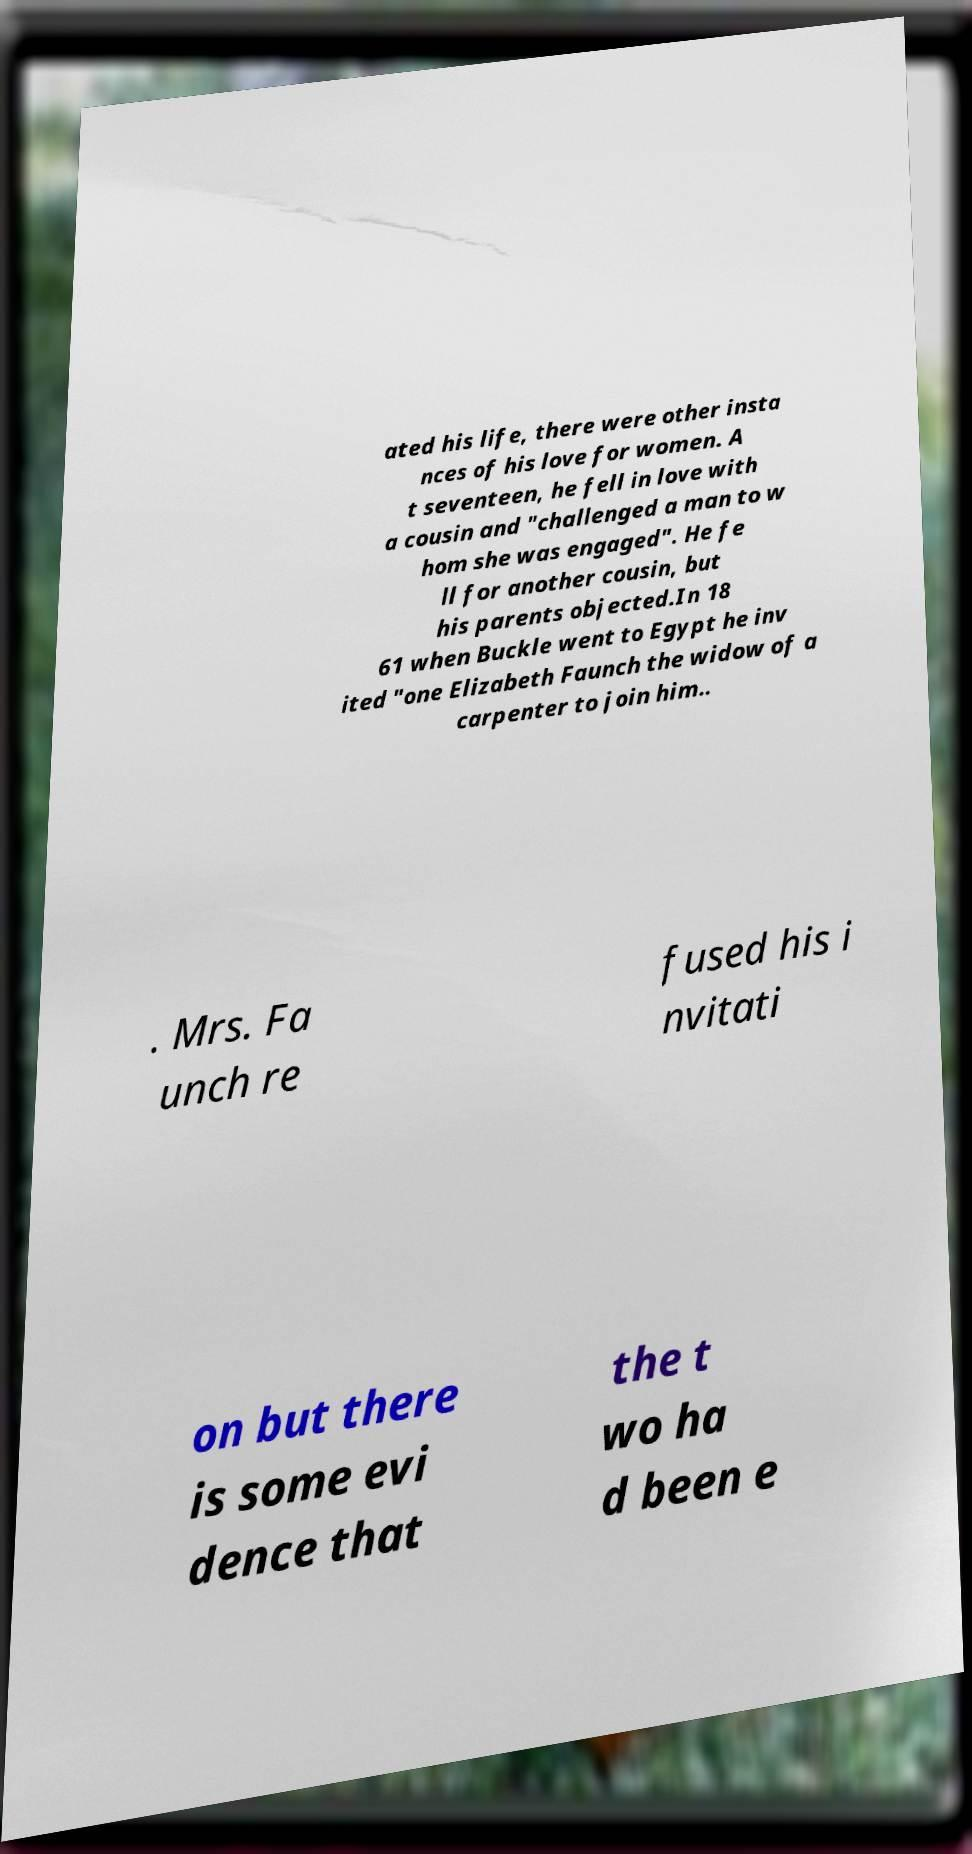Can you read and provide the text displayed in the image?This photo seems to have some interesting text. Can you extract and type it out for me? ated his life, there were other insta nces of his love for women. A t seventeen, he fell in love with a cousin and "challenged a man to w hom she was engaged". He fe ll for another cousin, but his parents objected.In 18 61 when Buckle went to Egypt he inv ited "one Elizabeth Faunch the widow of a carpenter to join him.. . Mrs. Fa unch re fused his i nvitati on but there is some evi dence that the t wo ha d been e 